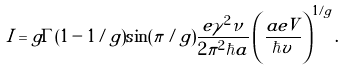<formula> <loc_0><loc_0><loc_500><loc_500>I = g \Gamma ( 1 - 1 / g ) \sin ( \pi / g ) \frac { e \gamma ^ { 2 } \nu } { 2 \pi ^ { 2 } \hbar { a } } \left ( \frac { a e V } { \hbar { v } } \right ) ^ { 1 / g } .</formula> 